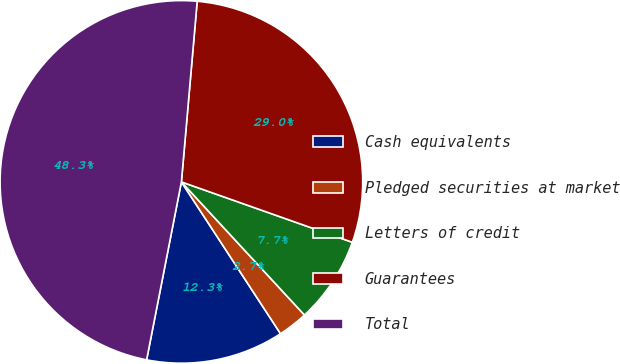Convert chart. <chart><loc_0><loc_0><loc_500><loc_500><pie_chart><fcel>Cash equivalents<fcel>Pledged securities at market<fcel>Letters of credit<fcel>Guarantees<fcel>Total<nl><fcel>12.28%<fcel>2.67%<fcel>7.72%<fcel>29.02%<fcel>48.32%<nl></chart> 